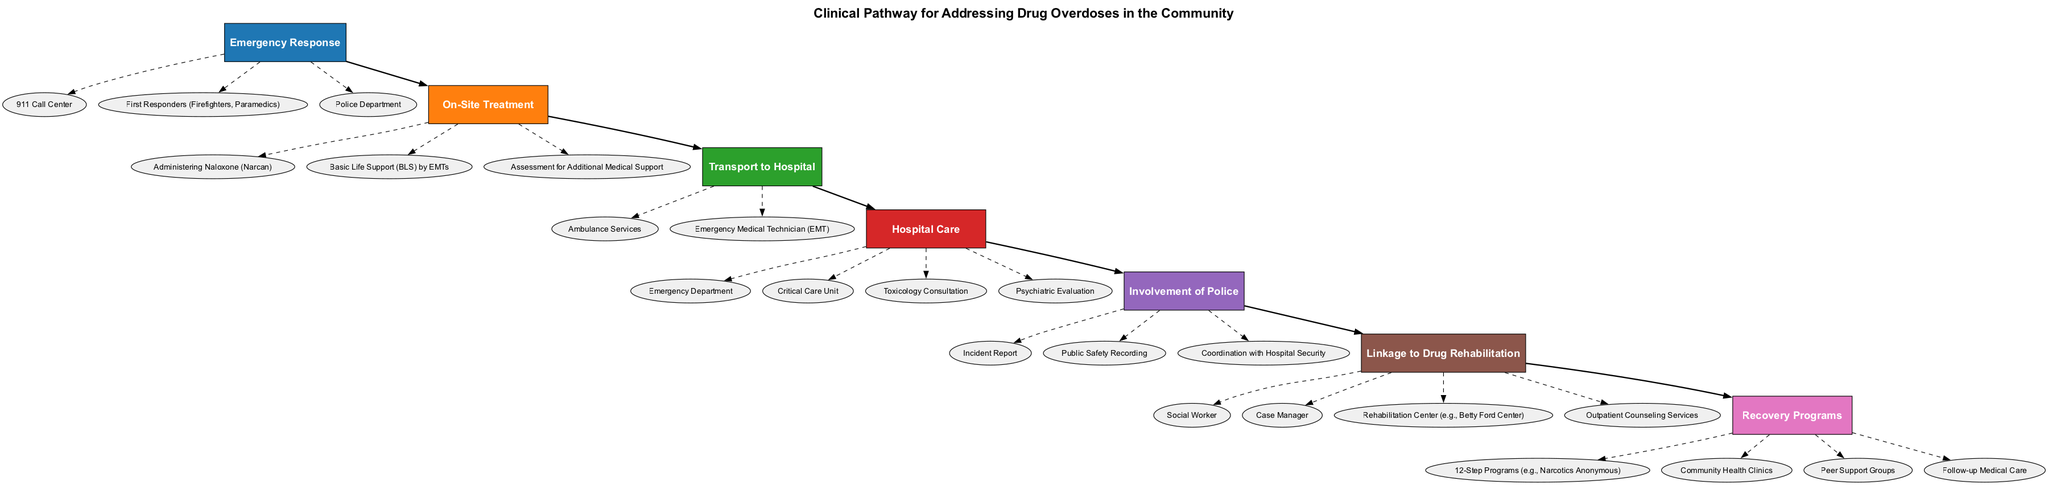What is the first step in the pathway? The first step in the pathway is "Emergency Response." This can be identified as it is the initial node listed in the sequence of steps depicted in the diagram.
Answer: Emergency Response How many entities are involved in On-Site Treatment? In the "On-Site Treatment" step, there are three entities listed. They are "Administering Naloxone (Narcan)," "Basic Life Support (BLS) by EMTs," and "Assessment for Additional Medical Support." Counting these entities gives the total as three.
Answer: 3 What comes after Transport to Hospital? Following the "Transport to Hospital" step, the next step is "Hospital Care." This can be determined by following the flow of the pathway as indicated by the connections between the nodes.
Answer: Hospital Care Which entity is connected to the Involvement of Police? The entities connected to the "Involvement of Police" step include "Incident Report," "Public Safety Recording," and "Coordination with Hospital Security." One example of an entity connected to this step is "Incident Report."
Answer: Incident Report What is the last step of the clinical pathway? The last step of the clinical pathway is "Recovery Programs." This is identified as it is the final node in the flow of steps, following "Linkage to Drug Rehabilitation."
Answer: Recovery Programs How many steps include the Police Department? The Police Department is mentioned in two steps: "Emergency Response" and "Involvement of Police." Thus, counting these mentioned occurrences indicates that the total is two steps.
Answer: 2 What is required for Hospital Care? The "Hospital Care" step mentions several entities, including "Emergency Department," "Critical Care Unit," "Toxicology Consultation," and "Psychiatric Evaluation." One entity that is required for this step is "Emergency Department."
Answer: Emergency Department Which step follows Linkage to Drug Rehabilitation? The step that follows "Linkage to Drug Rehabilitation" is "Recovery Programs." This is apparent from the sequential flow illustrated in the diagram.
Answer: Recovery Programs 